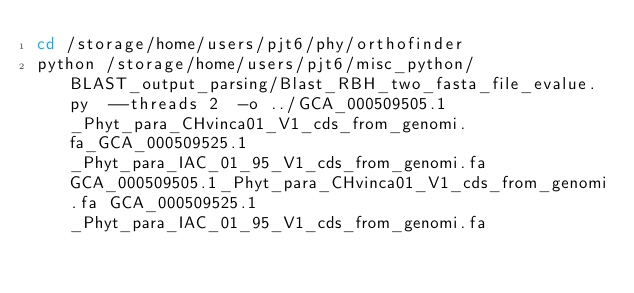<code> <loc_0><loc_0><loc_500><loc_500><_Bash_>cd /storage/home/users/pjt6/phy/orthofinder
python /storage/home/users/pjt6/misc_python/BLAST_output_parsing/Blast_RBH_two_fasta_file_evalue.py  --threads 2  -o ../GCA_000509505.1_Phyt_para_CHvinca01_V1_cds_from_genomi.fa_GCA_000509525.1_Phyt_para_IAC_01_95_V1_cds_from_genomi.fa GCA_000509505.1_Phyt_para_CHvinca01_V1_cds_from_genomi.fa GCA_000509525.1_Phyt_para_IAC_01_95_V1_cds_from_genomi.fa</code> 